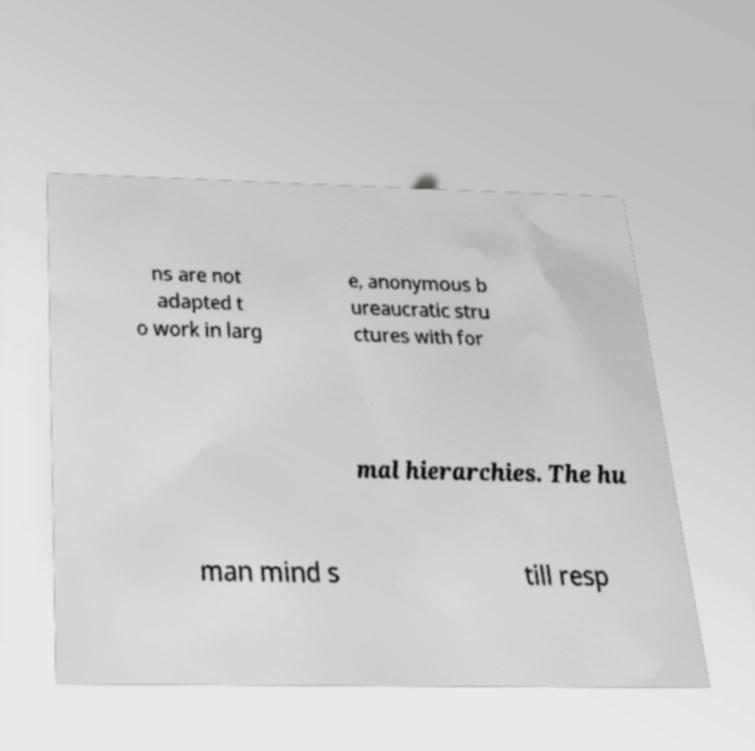There's text embedded in this image that I need extracted. Can you transcribe it verbatim? ns are not adapted t o work in larg e, anonymous b ureaucratic stru ctures with for mal hierarchies. The hu man mind s till resp 